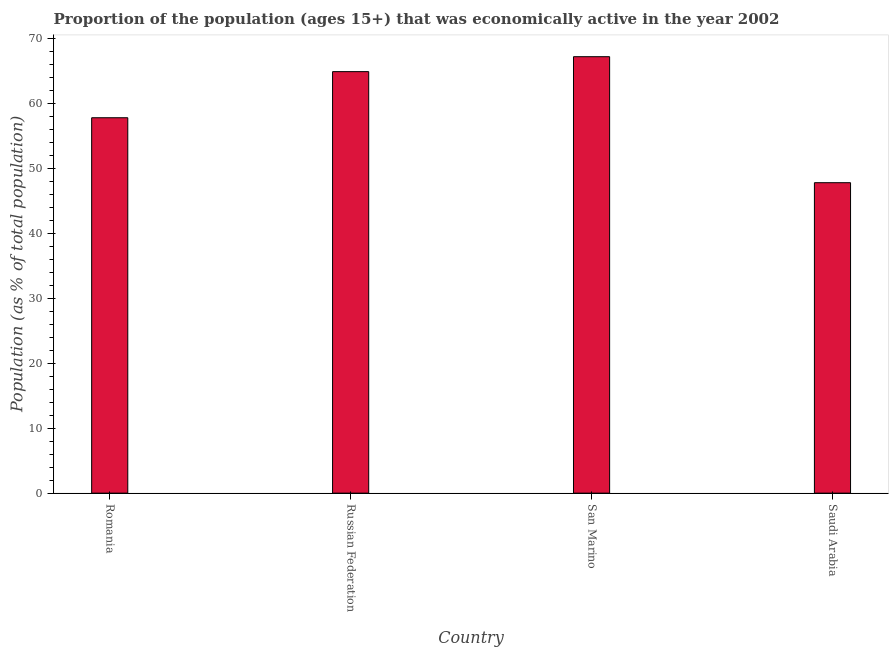What is the title of the graph?
Offer a terse response. Proportion of the population (ages 15+) that was economically active in the year 2002. What is the label or title of the Y-axis?
Provide a succinct answer. Population (as % of total population). What is the percentage of economically active population in San Marino?
Give a very brief answer. 67.2. Across all countries, what is the maximum percentage of economically active population?
Give a very brief answer. 67.2. Across all countries, what is the minimum percentage of economically active population?
Provide a succinct answer. 47.8. In which country was the percentage of economically active population maximum?
Make the answer very short. San Marino. In which country was the percentage of economically active population minimum?
Give a very brief answer. Saudi Arabia. What is the sum of the percentage of economically active population?
Offer a very short reply. 237.7. What is the difference between the percentage of economically active population in Romania and Saudi Arabia?
Offer a terse response. 10. What is the average percentage of economically active population per country?
Make the answer very short. 59.42. What is the median percentage of economically active population?
Ensure brevity in your answer.  61.35. What is the ratio of the percentage of economically active population in Romania to that in Russian Federation?
Provide a succinct answer. 0.89. Is the difference between the percentage of economically active population in Russian Federation and Saudi Arabia greater than the difference between any two countries?
Your answer should be compact. No. Is the sum of the percentage of economically active population in San Marino and Saudi Arabia greater than the maximum percentage of economically active population across all countries?
Keep it short and to the point. Yes. How many bars are there?
Your answer should be very brief. 4. Are all the bars in the graph horizontal?
Offer a very short reply. No. Are the values on the major ticks of Y-axis written in scientific E-notation?
Ensure brevity in your answer.  No. What is the Population (as % of total population) in Romania?
Offer a very short reply. 57.8. What is the Population (as % of total population) in Russian Federation?
Provide a succinct answer. 64.9. What is the Population (as % of total population) in San Marino?
Provide a succinct answer. 67.2. What is the Population (as % of total population) in Saudi Arabia?
Your response must be concise. 47.8. What is the difference between the Population (as % of total population) in Romania and Russian Federation?
Keep it short and to the point. -7.1. What is the difference between the Population (as % of total population) in Romania and San Marino?
Offer a terse response. -9.4. What is the difference between the Population (as % of total population) in San Marino and Saudi Arabia?
Provide a succinct answer. 19.4. What is the ratio of the Population (as % of total population) in Romania to that in Russian Federation?
Offer a terse response. 0.89. What is the ratio of the Population (as % of total population) in Romania to that in San Marino?
Keep it short and to the point. 0.86. What is the ratio of the Population (as % of total population) in Romania to that in Saudi Arabia?
Provide a succinct answer. 1.21. What is the ratio of the Population (as % of total population) in Russian Federation to that in Saudi Arabia?
Give a very brief answer. 1.36. What is the ratio of the Population (as % of total population) in San Marino to that in Saudi Arabia?
Your response must be concise. 1.41. 